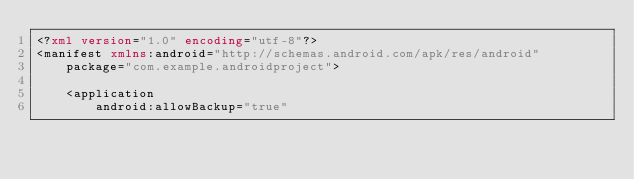Convert code to text. <code><loc_0><loc_0><loc_500><loc_500><_XML_><?xml version="1.0" encoding="utf-8"?>
<manifest xmlns:android="http://schemas.android.com/apk/res/android"
    package="com.example.androidproject">

    <application
        android:allowBackup="true"</code> 